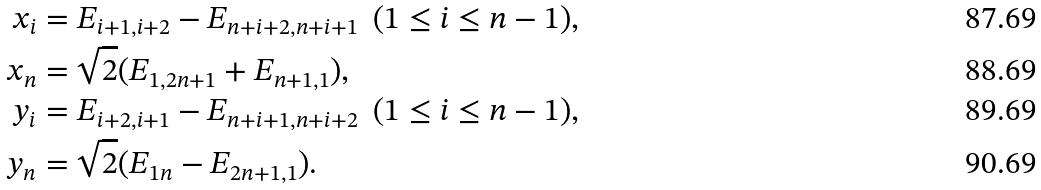Convert formula to latex. <formula><loc_0><loc_0><loc_500><loc_500>x _ { i } & = E _ { i + 1 , i + 2 } - E _ { n + i + 2 , n + i + 1 } \ \ ( 1 \leq i \leq n - 1 ) , \\ x _ { n } & = \sqrt { 2 } ( E _ { 1 , 2 n + 1 } + E _ { n + 1 , 1 } ) , \\ y _ { i } & = E _ { i + 2 , i + 1 } - E _ { n + i + 1 , n + i + 2 } \ \ ( 1 \leq i \leq n - 1 ) , \\ y _ { n } & = \sqrt { 2 } ( E _ { 1 n } - E _ { 2 n + 1 , 1 } ) .</formula> 